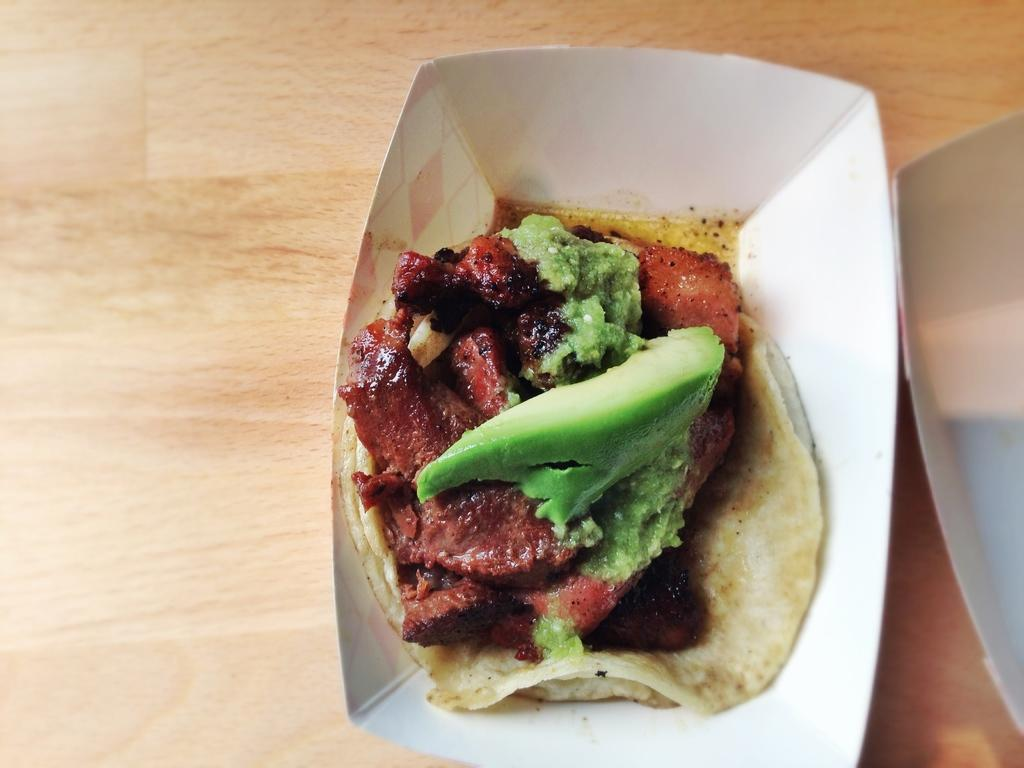What is in the bowl that is visible in the image? There is a paper bowl with food in the image. Where is the paper bowl placed in the image? The paper bowl is placed on a wooden table. What type of cloth is draped over the table in the image? There is no cloth draped over the table in the image; it is a wooden table with no additional coverings. 